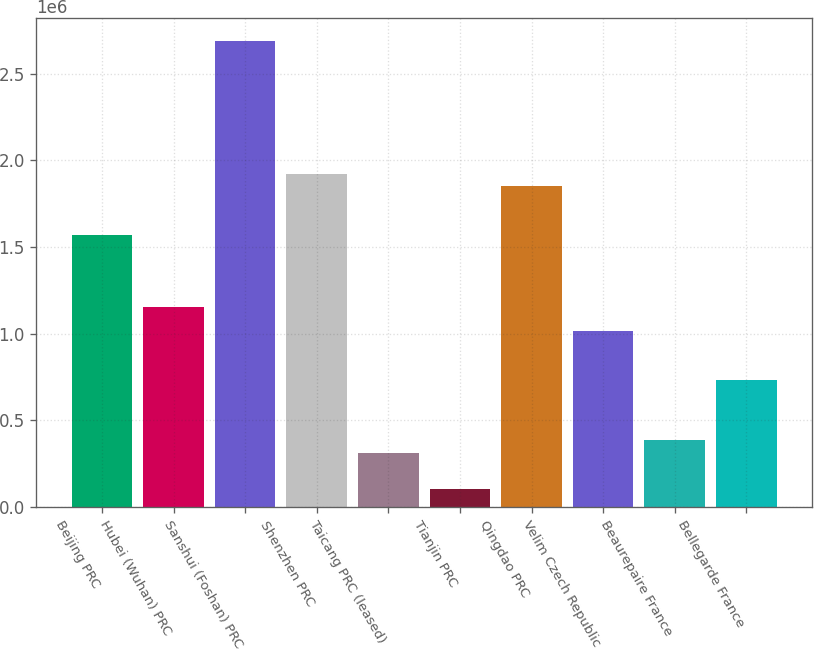<chart> <loc_0><loc_0><loc_500><loc_500><bar_chart><fcel>Beijing PRC<fcel>Hubei (Wuhan) PRC<fcel>Sanshui (Foshan) PRC<fcel>Shenzhen PRC<fcel>Taicang PRC (leased)<fcel>Tianjin PRC<fcel>Qingdao PRC<fcel>Velim Czech Republic<fcel>Beaurepaire France<fcel>Bellegarde France<nl><fcel>1.5718e+06<fcel>1.1524e+06<fcel>2.6902e+06<fcel>1.9213e+06<fcel>313600<fcel>103900<fcel>1.8514e+06<fcel>1.0126e+06<fcel>383500<fcel>733000<nl></chart> 